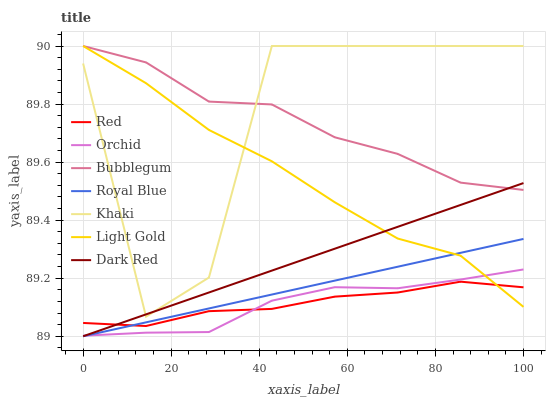Does Orchid have the minimum area under the curve?
Answer yes or no. Yes. Does Khaki have the maximum area under the curve?
Answer yes or no. Yes. Does Dark Red have the minimum area under the curve?
Answer yes or no. No. Does Dark Red have the maximum area under the curve?
Answer yes or no. No. Is Dark Red the smoothest?
Answer yes or no. Yes. Is Khaki the roughest?
Answer yes or no. Yes. Is Bubblegum the smoothest?
Answer yes or no. No. Is Bubblegum the roughest?
Answer yes or no. No. Does Dark Red have the lowest value?
Answer yes or no. Yes. Does Bubblegum have the lowest value?
Answer yes or no. No. Does Light Gold have the highest value?
Answer yes or no. Yes. Does Dark Red have the highest value?
Answer yes or no. No. Is Royal Blue less than Khaki?
Answer yes or no. Yes. Is Khaki greater than Orchid?
Answer yes or no. Yes. Does Dark Red intersect Royal Blue?
Answer yes or no. Yes. Is Dark Red less than Royal Blue?
Answer yes or no. No. Is Dark Red greater than Royal Blue?
Answer yes or no. No. Does Royal Blue intersect Khaki?
Answer yes or no. No. 